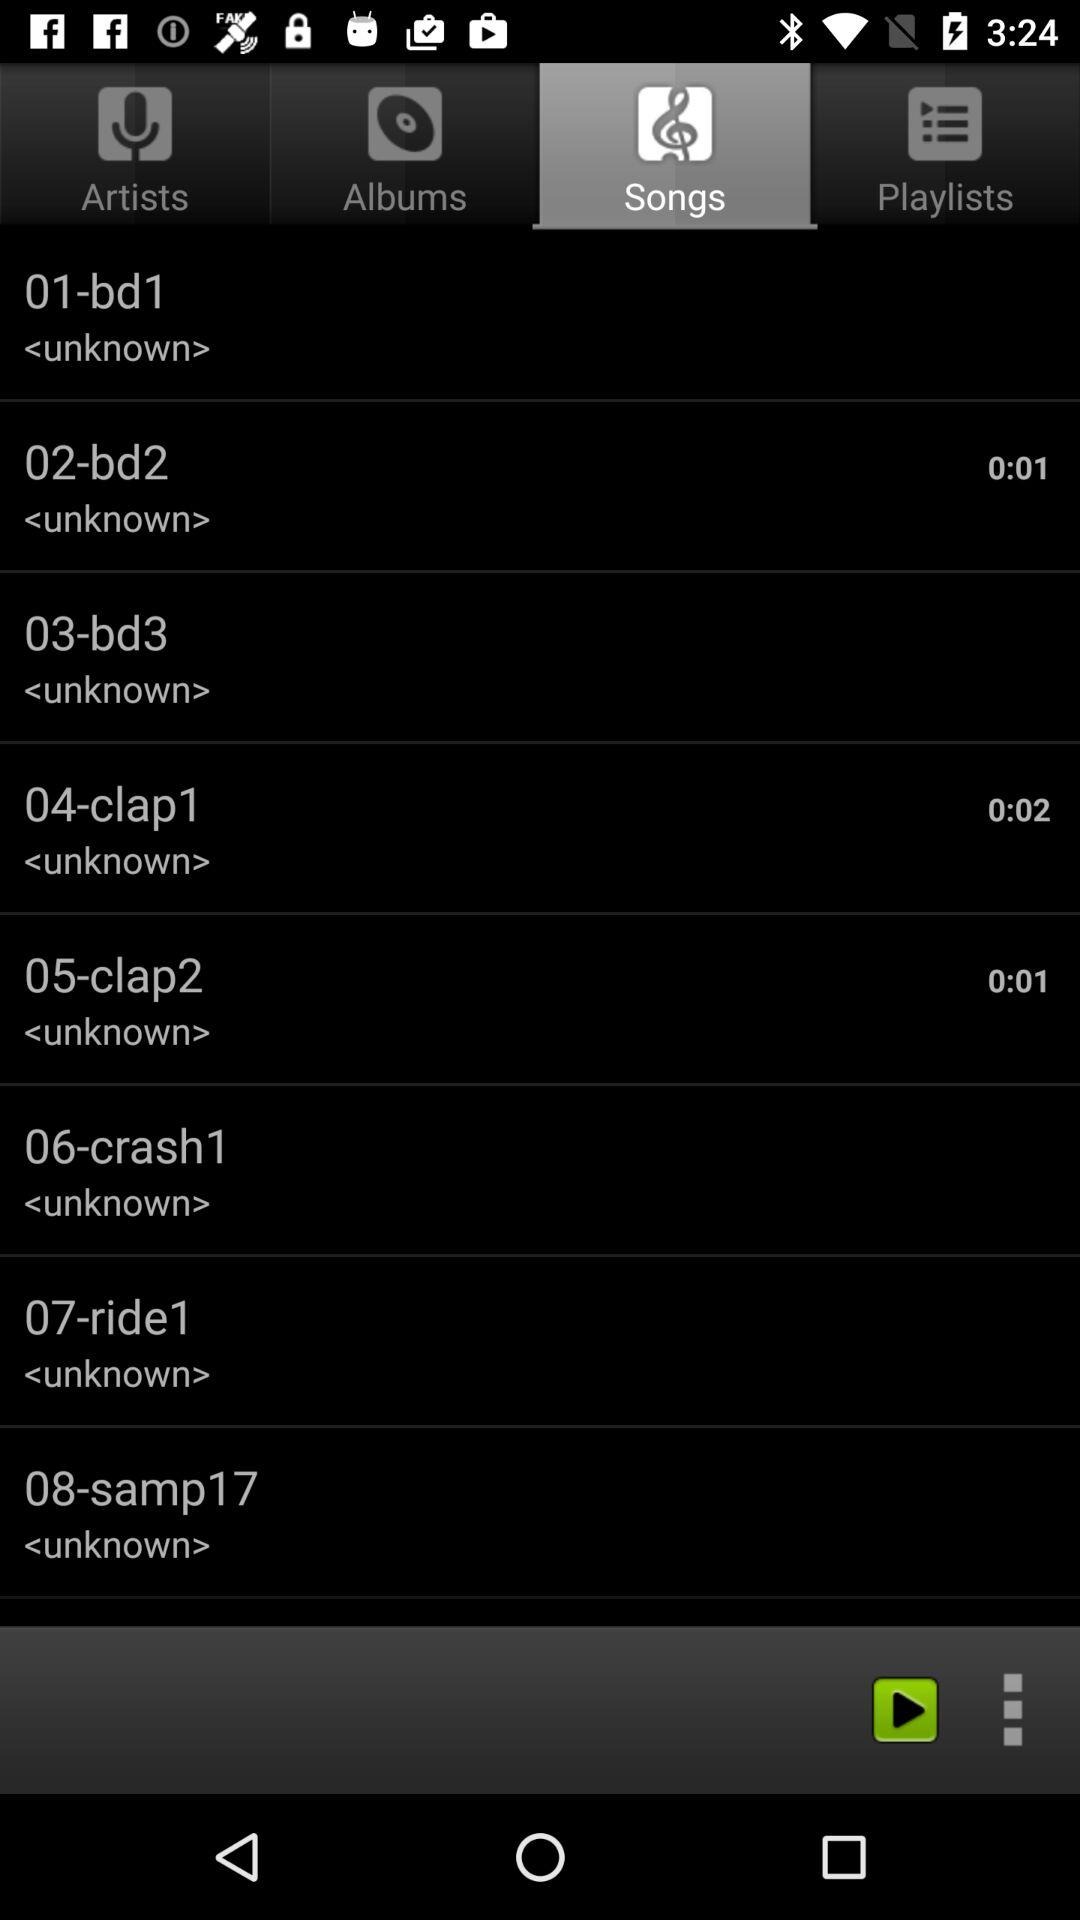How long is the longest audio clip?
Answer the question using a single word or phrase. 0:02 